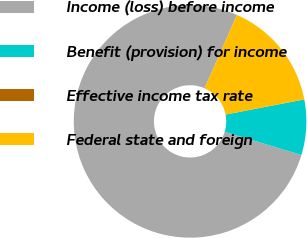<chart> <loc_0><loc_0><loc_500><loc_500><pie_chart><fcel>Income (loss) before income<fcel>Benefit (provision) for income<fcel>Effective income tax rate<fcel>Federal state and foreign<nl><fcel>76.92%<fcel>7.69%<fcel>0.0%<fcel>15.38%<nl></chart> 